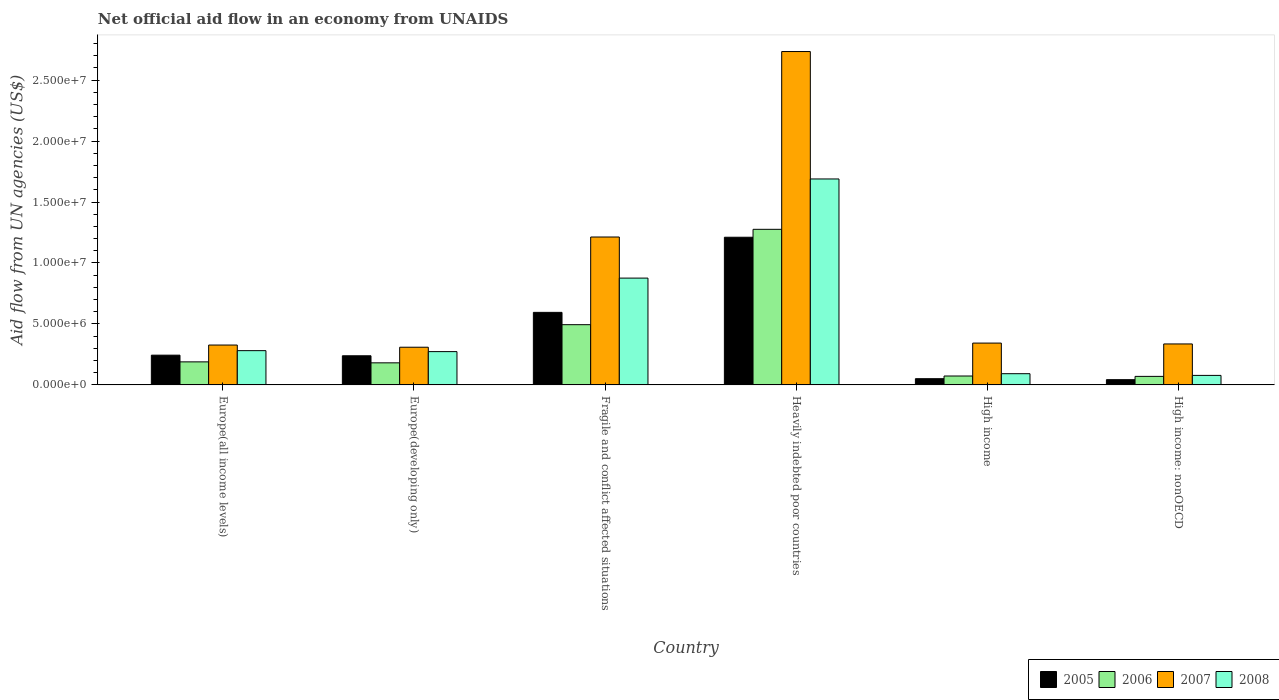How many different coloured bars are there?
Your response must be concise. 4. Are the number of bars per tick equal to the number of legend labels?
Make the answer very short. Yes. Are the number of bars on each tick of the X-axis equal?
Your response must be concise. Yes. How many bars are there on the 1st tick from the left?
Give a very brief answer. 4. How many bars are there on the 4th tick from the right?
Offer a terse response. 4. What is the label of the 3rd group of bars from the left?
Your response must be concise. Fragile and conflict affected situations. In how many cases, is the number of bars for a given country not equal to the number of legend labels?
Offer a very short reply. 0. What is the net official aid flow in 2008 in Europe(developing only)?
Provide a short and direct response. 2.73e+06. Across all countries, what is the maximum net official aid flow in 2005?
Provide a succinct answer. 1.21e+07. Across all countries, what is the minimum net official aid flow in 2005?
Your answer should be very brief. 4.30e+05. In which country was the net official aid flow in 2005 maximum?
Provide a succinct answer. Heavily indebted poor countries. In which country was the net official aid flow in 2005 minimum?
Offer a very short reply. High income: nonOECD. What is the total net official aid flow in 2007 in the graph?
Ensure brevity in your answer.  5.26e+07. What is the difference between the net official aid flow in 2008 in Fragile and conflict affected situations and that in Heavily indebted poor countries?
Your answer should be very brief. -8.13e+06. What is the difference between the net official aid flow in 2008 in High income: nonOECD and the net official aid flow in 2007 in Fragile and conflict affected situations?
Offer a very short reply. -1.14e+07. What is the average net official aid flow in 2007 per country?
Offer a very short reply. 8.77e+06. What is the difference between the net official aid flow of/in 2006 and net official aid flow of/in 2008 in Fragile and conflict affected situations?
Provide a short and direct response. -3.82e+06. What is the ratio of the net official aid flow in 2005 in Europe(developing only) to that in Heavily indebted poor countries?
Your response must be concise. 0.2. Is the net official aid flow in 2005 in Europe(all income levels) less than that in Europe(developing only)?
Your answer should be compact. No. Is the difference between the net official aid flow in 2006 in Europe(developing only) and Heavily indebted poor countries greater than the difference between the net official aid flow in 2008 in Europe(developing only) and Heavily indebted poor countries?
Provide a short and direct response. Yes. What is the difference between the highest and the second highest net official aid flow in 2005?
Make the answer very short. 6.16e+06. What is the difference between the highest and the lowest net official aid flow in 2007?
Your response must be concise. 2.42e+07. In how many countries, is the net official aid flow in 2008 greater than the average net official aid flow in 2008 taken over all countries?
Keep it short and to the point. 2. Is it the case that in every country, the sum of the net official aid flow in 2005 and net official aid flow in 2007 is greater than the sum of net official aid flow in 2008 and net official aid flow in 2006?
Give a very brief answer. No. Is it the case that in every country, the sum of the net official aid flow in 2006 and net official aid flow in 2005 is greater than the net official aid flow in 2007?
Offer a very short reply. No. Does the graph contain any zero values?
Make the answer very short. No. Where does the legend appear in the graph?
Offer a very short reply. Bottom right. What is the title of the graph?
Keep it short and to the point. Net official aid flow in an economy from UNAIDS. What is the label or title of the X-axis?
Your answer should be very brief. Country. What is the label or title of the Y-axis?
Offer a terse response. Aid flow from UN agencies (US$). What is the Aid flow from UN agencies (US$) of 2005 in Europe(all income levels)?
Your answer should be compact. 2.44e+06. What is the Aid flow from UN agencies (US$) in 2006 in Europe(all income levels)?
Your response must be concise. 1.89e+06. What is the Aid flow from UN agencies (US$) in 2007 in Europe(all income levels)?
Provide a short and direct response. 3.27e+06. What is the Aid flow from UN agencies (US$) of 2008 in Europe(all income levels)?
Offer a terse response. 2.81e+06. What is the Aid flow from UN agencies (US$) of 2005 in Europe(developing only)?
Ensure brevity in your answer.  2.39e+06. What is the Aid flow from UN agencies (US$) in 2006 in Europe(developing only)?
Give a very brief answer. 1.81e+06. What is the Aid flow from UN agencies (US$) of 2007 in Europe(developing only)?
Your answer should be compact. 3.09e+06. What is the Aid flow from UN agencies (US$) in 2008 in Europe(developing only)?
Your answer should be very brief. 2.73e+06. What is the Aid flow from UN agencies (US$) in 2005 in Fragile and conflict affected situations?
Make the answer very short. 5.95e+06. What is the Aid flow from UN agencies (US$) in 2006 in Fragile and conflict affected situations?
Ensure brevity in your answer.  4.94e+06. What is the Aid flow from UN agencies (US$) of 2007 in Fragile and conflict affected situations?
Keep it short and to the point. 1.21e+07. What is the Aid flow from UN agencies (US$) in 2008 in Fragile and conflict affected situations?
Make the answer very short. 8.76e+06. What is the Aid flow from UN agencies (US$) of 2005 in Heavily indebted poor countries?
Give a very brief answer. 1.21e+07. What is the Aid flow from UN agencies (US$) of 2006 in Heavily indebted poor countries?
Provide a succinct answer. 1.28e+07. What is the Aid flow from UN agencies (US$) of 2007 in Heavily indebted poor countries?
Ensure brevity in your answer.  2.73e+07. What is the Aid flow from UN agencies (US$) of 2008 in Heavily indebted poor countries?
Offer a terse response. 1.69e+07. What is the Aid flow from UN agencies (US$) of 2005 in High income?
Your response must be concise. 5.10e+05. What is the Aid flow from UN agencies (US$) in 2006 in High income?
Your response must be concise. 7.30e+05. What is the Aid flow from UN agencies (US$) of 2007 in High income?
Your answer should be compact. 3.43e+06. What is the Aid flow from UN agencies (US$) of 2008 in High income?
Your answer should be compact. 9.20e+05. What is the Aid flow from UN agencies (US$) in 2007 in High income: nonOECD?
Make the answer very short. 3.36e+06. What is the Aid flow from UN agencies (US$) of 2008 in High income: nonOECD?
Make the answer very short. 7.80e+05. Across all countries, what is the maximum Aid flow from UN agencies (US$) of 2005?
Your response must be concise. 1.21e+07. Across all countries, what is the maximum Aid flow from UN agencies (US$) of 2006?
Provide a succinct answer. 1.28e+07. Across all countries, what is the maximum Aid flow from UN agencies (US$) in 2007?
Make the answer very short. 2.73e+07. Across all countries, what is the maximum Aid flow from UN agencies (US$) in 2008?
Offer a terse response. 1.69e+07. Across all countries, what is the minimum Aid flow from UN agencies (US$) in 2007?
Offer a very short reply. 3.09e+06. Across all countries, what is the minimum Aid flow from UN agencies (US$) of 2008?
Make the answer very short. 7.80e+05. What is the total Aid flow from UN agencies (US$) in 2005 in the graph?
Give a very brief answer. 2.38e+07. What is the total Aid flow from UN agencies (US$) in 2006 in the graph?
Provide a short and direct response. 2.28e+07. What is the total Aid flow from UN agencies (US$) of 2007 in the graph?
Your answer should be compact. 5.26e+07. What is the total Aid flow from UN agencies (US$) of 2008 in the graph?
Keep it short and to the point. 3.29e+07. What is the difference between the Aid flow from UN agencies (US$) in 2005 in Europe(all income levels) and that in Europe(developing only)?
Your answer should be compact. 5.00e+04. What is the difference between the Aid flow from UN agencies (US$) of 2005 in Europe(all income levels) and that in Fragile and conflict affected situations?
Keep it short and to the point. -3.51e+06. What is the difference between the Aid flow from UN agencies (US$) of 2006 in Europe(all income levels) and that in Fragile and conflict affected situations?
Ensure brevity in your answer.  -3.05e+06. What is the difference between the Aid flow from UN agencies (US$) of 2007 in Europe(all income levels) and that in Fragile and conflict affected situations?
Offer a terse response. -8.86e+06. What is the difference between the Aid flow from UN agencies (US$) of 2008 in Europe(all income levels) and that in Fragile and conflict affected situations?
Your response must be concise. -5.95e+06. What is the difference between the Aid flow from UN agencies (US$) of 2005 in Europe(all income levels) and that in Heavily indebted poor countries?
Offer a very short reply. -9.67e+06. What is the difference between the Aid flow from UN agencies (US$) of 2006 in Europe(all income levels) and that in Heavily indebted poor countries?
Provide a succinct answer. -1.09e+07. What is the difference between the Aid flow from UN agencies (US$) in 2007 in Europe(all income levels) and that in Heavily indebted poor countries?
Keep it short and to the point. -2.41e+07. What is the difference between the Aid flow from UN agencies (US$) in 2008 in Europe(all income levels) and that in Heavily indebted poor countries?
Give a very brief answer. -1.41e+07. What is the difference between the Aid flow from UN agencies (US$) in 2005 in Europe(all income levels) and that in High income?
Offer a terse response. 1.93e+06. What is the difference between the Aid flow from UN agencies (US$) of 2006 in Europe(all income levels) and that in High income?
Offer a very short reply. 1.16e+06. What is the difference between the Aid flow from UN agencies (US$) in 2007 in Europe(all income levels) and that in High income?
Your response must be concise. -1.60e+05. What is the difference between the Aid flow from UN agencies (US$) of 2008 in Europe(all income levels) and that in High income?
Provide a succinct answer. 1.89e+06. What is the difference between the Aid flow from UN agencies (US$) of 2005 in Europe(all income levels) and that in High income: nonOECD?
Provide a short and direct response. 2.01e+06. What is the difference between the Aid flow from UN agencies (US$) in 2006 in Europe(all income levels) and that in High income: nonOECD?
Your answer should be compact. 1.19e+06. What is the difference between the Aid flow from UN agencies (US$) of 2007 in Europe(all income levels) and that in High income: nonOECD?
Your answer should be very brief. -9.00e+04. What is the difference between the Aid flow from UN agencies (US$) in 2008 in Europe(all income levels) and that in High income: nonOECD?
Keep it short and to the point. 2.03e+06. What is the difference between the Aid flow from UN agencies (US$) in 2005 in Europe(developing only) and that in Fragile and conflict affected situations?
Provide a short and direct response. -3.56e+06. What is the difference between the Aid flow from UN agencies (US$) in 2006 in Europe(developing only) and that in Fragile and conflict affected situations?
Your response must be concise. -3.13e+06. What is the difference between the Aid flow from UN agencies (US$) of 2007 in Europe(developing only) and that in Fragile and conflict affected situations?
Offer a terse response. -9.04e+06. What is the difference between the Aid flow from UN agencies (US$) in 2008 in Europe(developing only) and that in Fragile and conflict affected situations?
Ensure brevity in your answer.  -6.03e+06. What is the difference between the Aid flow from UN agencies (US$) of 2005 in Europe(developing only) and that in Heavily indebted poor countries?
Make the answer very short. -9.72e+06. What is the difference between the Aid flow from UN agencies (US$) of 2006 in Europe(developing only) and that in Heavily indebted poor countries?
Give a very brief answer. -1.10e+07. What is the difference between the Aid flow from UN agencies (US$) in 2007 in Europe(developing only) and that in Heavily indebted poor countries?
Offer a terse response. -2.42e+07. What is the difference between the Aid flow from UN agencies (US$) of 2008 in Europe(developing only) and that in Heavily indebted poor countries?
Provide a succinct answer. -1.42e+07. What is the difference between the Aid flow from UN agencies (US$) of 2005 in Europe(developing only) and that in High income?
Your answer should be very brief. 1.88e+06. What is the difference between the Aid flow from UN agencies (US$) of 2006 in Europe(developing only) and that in High income?
Your answer should be very brief. 1.08e+06. What is the difference between the Aid flow from UN agencies (US$) of 2008 in Europe(developing only) and that in High income?
Provide a short and direct response. 1.81e+06. What is the difference between the Aid flow from UN agencies (US$) of 2005 in Europe(developing only) and that in High income: nonOECD?
Offer a very short reply. 1.96e+06. What is the difference between the Aid flow from UN agencies (US$) of 2006 in Europe(developing only) and that in High income: nonOECD?
Your answer should be very brief. 1.11e+06. What is the difference between the Aid flow from UN agencies (US$) in 2008 in Europe(developing only) and that in High income: nonOECD?
Your answer should be compact. 1.95e+06. What is the difference between the Aid flow from UN agencies (US$) of 2005 in Fragile and conflict affected situations and that in Heavily indebted poor countries?
Provide a succinct answer. -6.16e+06. What is the difference between the Aid flow from UN agencies (US$) of 2006 in Fragile and conflict affected situations and that in Heavily indebted poor countries?
Your answer should be compact. -7.82e+06. What is the difference between the Aid flow from UN agencies (US$) of 2007 in Fragile and conflict affected situations and that in Heavily indebted poor countries?
Offer a terse response. -1.52e+07. What is the difference between the Aid flow from UN agencies (US$) of 2008 in Fragile and conflict affected situations and that in Heavily indebted poor countries?
Offer a terse response. -8.13e+06. What is the difference between the Aid flow from UN agencies (US$) in 2005 in Fragile and conflict affected situations and that in High income?
Provide a succinct answer. 5.44e+06. What is the difference between the Aid flow from UN agencies (US$) of 2006 in Fragile and conflict affected situations and that in High income?
Offer a very short reply. 4.21e+06. What is the difference between the Aid flow from UN agencies (US$) in 2007 in Fragile and conflict affected situations and that in High income?
Provide a short and direct response. 8.70e+06. What is the difference between the Aid flow from UN agencies (US$) of 2008 in Fragile and conflict affected situations and that in High income?
Your response must be concise. 7.84e+06. What is the difference between the Aid flow from UN agencies (US$) in 2005 in Fragile and conflict affected situations and that in High income: nonOECD?
Your answer should be very brief. 5.52e+06. What is the difference between the Aid flow from UN agencies (US$) in 2006 in Fragile and conflict affected situations and that in High income: nonOECD?
Ensure brevity in your answer.  4.24e+06. What is the difference between the Aid flow from UN agencies (US$) in 2007 in Fragile and conflict affected situations and that in High income: nonOECD?
Keep it short and to the point. 8.77e+06. What is the difference between the Aid flow from UN agencies (US$) in 2008 in Fragile and conflict affected situations and that in High income: nonOECD?
Make the answer very short. 7.98e+06. What is the difference between the Aid flow from UN agencies (US$) in 2005 in Heavily indebted poor countries and that in High income?
Your answer should be compact. 1.16e+07. What is the difference between the Aid flow from UN agencies (US$) in 2006 in Heavily indebted poor countries and that in High income?
Make the answer very short. 1.20e+07. What is the difference between the Aid flow from UN agencies (US$) of 2007 in Heavily indebted poor countries and that in High income?
Give a very brief answer. 2.39e+07. What is the difference between the Aid flow from UN agencies (US$) in 2008 in Heavily indebted poor countries and that in High income?
Give a very brief answer. 1.60e+07. What is the difference between the Aid flow from UN agencies (US$) of 2005 in Heavily indebted poor countries and that in High income: nonOECD?
Your response must be concise. 1.17e+07. What is the difference between the Aid flow from UN agencies (US$) in 2006 in Heavily indebted poor countries and that in High income: nonOECD?
Provide a succinct answer. 1.21e+07. What is the difference between the Aid flow from UN agencies (US$) of 2007 in Heavily indebted poor countries and that in High income: nonOECD?
Offer a very short reply. 2.40e+07. What is the difference between the Aid flow from UN agencies (US$) in 2008 in Heavily indebted poor countries and that in High income: nonOECD?
Your answer should be compact. 1.61e+07. What is the difference between the Aid flow from UN agencies (US$) in 2005 in High income and that in High income: nonOECD?
Make the answer very short. 8.00e+04. What is the difference between the Aid flow from UN agencies (US$) in 2007 in High income and that in High income: nonOECD?
Keep it short and to the point. 7.00e+04. What is the difference between the Aid flow from UN agencies (US$) in 2005 in Europe(all income levels) and the Aid flow from UN agencies (US$) in 2006 in Europe(developing only)?
Keep it short and to the point. 6.30e+05. What is the difference between the Aid flow from UN agencies (US$) in 2005 in Europe(all income levels) and the Aid flow from UN agencies (US$) in 2007 in Europe(developing only)?
Provide a short and direct response. -6.50e+05. What is the difference between the Aid flow from UN agencies (US$) in 2005 in Europe(all income levels) and the Aid flow from UN agencies (US$) in 2008 in Europe(developing only)?
Give a very brief answer. -2.90e+05. What is the difference between the Aid flow from UN agencies (US$) of 2006 in Europe(all income levels) and the Aid flow from UN agencies (US$) of 2007 in Europe(developing only)?
Your response must be concise. -1.20e+06. What is the difference between the Aid flow from UN agencies (US$) of 2006 in Europe(all income levels) and the Aid flow from UN agencies (US$) of 2008 in Europe(developing only)?
Offer a very short reply. -8.40e+05. What is the difference between the Aid flow from UN agencies (US$) in 2007 in Europe(all income levels) and the Aid flow from UN agencies (US$) in 2008 in Europe(developing only)?
Give a very brief answer. 5.40e+05. What is the difference between the Aid flow from UN agencies (US$) in 2005 in Europe(all income levels) and the Aid flow from UN agencies (US$) in 2006 in Fragile and conflict affected situations?
Keep it short and to the point. -2.50e+06. What is the difference between the Aid flow from UN agencies (US$) in 2005 in Europe(all income levels) and the Aid flow from UN agencies (US$) in 2007 in Fragile and conflict affected situations?
Ensure brevity in your answer.  -9.69e+06. What is the difference between the Aid flow from UN agencies (US$) in 2005 in Europe(all income levels) and the Aid flow from UN agencies (US$) in 2008 in Fragile and conflict affected situations?
Offer a terse response. -6.32e+06. What is the difference between the Aid flow from UN agencies (US$) in 2006 in Europe(all income levels) and the Aid flow from UN agencies (US$) in 2007 in Fragile and conflict affected situations?
Provide a short and direct response. -1.02e+07. What is the difference between the Aid flow from UN agencies (US$) in 2006 in Europe(all income levels) and the Aid flow from UN agencies (US$) in 2008 in Fragile and conflict affected situations?
Your answer should be very brief. -6.87e+06. What is the difference between the Aid flow from UN agencies (US$) in 2007 in Europe(all income levels) and the Aid flow from UN agencies (US$) in 2008 in Fragile and conflict affected situations?
Make the answer very short. -5.49e+06. What is the difference between the Aid flow from UN agencies (US$) of 2005 in Europe(all income levels) and the Aid flow from UN agencies (US$) of 2006 in Heavily indebted poor countries?
Offer a terse response. -1.03e+07. What is the difference between the Aid flow from UN agencies (US$) of 2005 in Europe(all income levels) and the Aid flow from UN agencies (US$) of 2007 in Heavily indebted poor countries?
Ensure brevity in your answer.  -2.49e+07. What is the difference between the Aid flow from UN agencies (US$) in 2005 in Europe(all income levels) and the Aid flow from UN agencies (US$) in 2008 in Heavily indebted poor countries?
Keep it short and to the point. -1.44e+07. What is the difference between the Aid flow from UN agencies (US$) in 2006 in Europe(all income levels) and the Aid flow from UN agencies (US$) in 2007 in Heavily indebted poor countries?
Provide a short and direct response. -2.54e+07. What is the difference between the Aid flow from UN agencies (US$) in 2006 in Europe(all income levels) and the Aid flow from UN agencies (US$) in 2008 in Heavily indebted poor countries?
Provide a short and direct response. -1.50e+07. What is the difference between the Aid flow from UN agencies (US$) in 2007 in Europe(all income levels) and the Aid flow from UN agencies (US$) in 2008 in Heavily indebted poor countries?
Keep it short and to the point. -1.36e+07. What is the difference between the Aid flow from UN agencies (US$) in 2005 in Europe(all income levels) and the Aid flow from UN agencies (US$) in 2006 in High income?
Provide a short and direct response. 1.71e+06. What is the difference between the Aid flow from UN agencies (US$) of 2005 in Europe(all income levels) and the Aid flow from UN agencies (US$) of 2007 in High income?
Your response must be concise. -9.90e+05. What is the difference between the Aid flow from UN agencies (US$) of 2005 in Europe(all income levels) and the Aid flow from UN agencies (US$) of 2008 in High income?
Offer a terse response. 1.52e+06. What is the difference between the Aid flow from UN agencies (US$) of 2006 in Europe(all income levels) and the Aid flow from UN agencies (US$) of 2007 in High income?
Keep it short and to the point. -1.54e+06. What is the difference between the Aid flow from UN agencies (US$) in 2006 in Europe(all income levels) and the Aid flow from UN agencies (US$) in 2008 in High income?
Your response must be concise. 9.70e+05. What is the difference between the Aid flow from UN agencies (US$) of 2007 in Europe(all income levels) and the Aid flow from UN agencies (US$) of 2008 in High income?
Make the answer very short. 2.35e+06. What is the difference between the Aid flow from UN agencies (US$) of 2005 in Europe(all income levels) and the Aid flow from UN agencies (US$) of 2006 in High income: nonOECD?
Your answer should be compact. 1.74e+06. What is the difference between the Aid flow from UN agencies (US$) of 2005 in Europe(all income levels) and the Aid flow from UN agencies (US$) of 2007 in High income: nonOECD?
Your answer should be compact. -9.20e+05. What is the difference between the Aid flow from UN agencies (US$) in 2005 in Europe(all income levels) and the Aid flow from UN agencies (US$) in 2008 in High income: nonOECD?
Provide a short and direct response. 1.66e+06. What is the difference between the Aid flow from UN agencies (US$) in 2006 in Europe(all income levels) and the Aid flow from UN agencies (US$) in 2007 in High income: nonOECD?
Offer a very short reply. -1.47e+06. What is the difference between the Aid flow from UN agencies (US$) in 2006 in Europe(all income levels) and the Aid flow from UN agencies (US$) in 2008 in High income: nonOECD?
Give a very brief answer. 1.11e+06. What is the difference between the Aid flow from UN agencies (US$) of 2007 in Europe(all income levels) and the Aid flow from UN agencies (US$) of 2008 in High income: nonOECD?
Ensure brevity in your answer.  2.49e+06. What is the difference between the Aid flow from UN agencies (US$) of 2005 in Europe(developing only) and the Aid flow from UN agencies (US$) of 2006 in Fragile and conflict affected situations?
Make the answer very short. -2.55e+06. What is the difference between the Aid flow from UN agencies (US$) in 2005 in Europe(developing only) and the Aid flow from UN agencies (US$) in 2007 in Fragile and conflict affected situations?
Provide a succinct answer. -9.74e+06. What is the difference between the Aid flow from UN agencies (US$) of 2005 in Europe(developing only) and the Aid flow from UN agencies (US$) of 2008 in Fragile and conflict affected situations?
Keep it short and to the point. -6.37e+06. What is the difference between the Aid flow from UN agencies (US$) in 2006 in Europe(developing only) and the Aid flow from UN agencies (US$) in 2007 in Fragile and conflict affected situations?
Offer a very short reply. -1.03e+07. What is the difference between the Aid flow from UN agencies (US$) in 2006 in Europe(developing only) and the Aid flow from UN agencies (US$) in 2008 in Fragile and conflict affected situations?
Your answer should be very brief. -6.95e+06. What is the difference between the Aid flow from UN agencies (US$) in 2007 in Europe(developing only) and the Aid flow from UN agencies (US$) in 2008 in Fragile and conflict affected situations?
Your answer should be compact. -5.67e+06. What is the difference between the Aid flow from UN agencies (US$) in 2005 in Europe(developing only) and the Aid flow from UN agencies (US$) in 2006 in Heavily indebted poor countries?
Offer a very short reply. -1.04e+07. What is the difference between the Aid flow from UN agencies (US$) of 2005 in Europe(developing only) and the Aid flow from UN agencies (US$) of 2007 in Heavily indebted poor countries?
Your answer should be very brief. -2.50e+07. What is the difference between the Aid flow from UN agencies (US$) in 2005 in Europe(developing only) and the Aid flow from UN agencies (US$) in 2008 in Heavily indebted poor countries?
Your answer should be very brief. -1.45e+07. What is the difference between the Aid flow from UN agencies (US$) of 2006 in Europe(developing only) and the Aid flow from UN agencies (US$) of 2007 in Heavily indebted poor countries?
Your answer should be very brief. -2.55e+07. What is the difference between the Aid flow from UN agencies (US$) of 2006 in Europe(developing only) and the Aid flow from UN agencies (US$) of 2008 in Heavily indebted poor countries?
Your answer should be very brief. -1.51e+07. What is the difference between the Aid flow from UN agencies (US$) in 2007 in Europe(developing only) and the Aid flow from UN agencies (US$) in 2008 in Heavily indebted poor countries?
Offer a terse response. -1.38e+07. What is the difference between the Aid flow from UN agencies (US$) of 2005 in Europe(developing only) and the Aid flow from UN agencies (US$) of 2006 in High income?
Give a very brief answer. 1.66e+06. What is the difference between the Aid flow from UN agencies (US$) of 2005 in Europe(developing only) and the Aid flow from UN agencies (US$) of 2007 in High income?
Ensure brevity in your answer.  -1.04e+06. What is the difference between the Aid flow from UN agencies (US$) in 2005 in Europe(developing only) and the Aid flow from UN agencies (US$) in 2008 in High income?
Offer a terse response. 1.47e+06. What is the difference between the Aid flow from UN agencies (US$) in 2006 in Europe(developing only) and the Aid flow from UN agencies (US$) in 2007 in High income?
Your answer should be compact. -1.62e+06. What is the difference between the Aid flow from UN agencies (US$) in 2006 in Europe(developing only) and the Aid flow from UN agencies (US$) in 2008 in High income?
Your answer should be very brief. 8.90e+05. What is the difference between the Aid flow from UN agencies (US$) of 2007 in Europe(developing only) and the Aid flow from UN agencies (US$) of 2008 in High income?
Provide a short and direct response. 2.17e+06. What is the difference between the Aid flow from UN agencies (US$) of 2005 in Europe(developing only) and the Aid flow from UN agencies (US$) of 2006 in High income: nonOECD?
Ensure brevity in your answer.  1.69e+06. What is the difference between the Aid flow from UN agencies (US$) in 2005 in Europe(developing only) and the Aid flow from UN agencies (US$) in 2007 in High income: nonOECD?
Provide a short and direct response. -9.70e+05. What is the difference between the Aid flow from UN agencies (US$) in 2005 in Europe(developing only) and the Aid flow from UN agencies (US$) in 2008 in High income: nonOECD?
Offer a terse response. 1.61e+06. What is the difference between the Aid flow from UN agencies (US$) in 2006 in Europe(developing only) and the Aid flow from UN agencies (US$) in 2007 in High income: nonOECD?
Make the answer very short. -1.55e+06. What is the difference between the Aid flow from UN agencies (US$) in 2006 in Europe(developing only) and the Aid flow from UN agencies (US$) in 2008 in High income: nonOECD?
Offer a very short reply. 1.03e+06. What is the difference between the Aid flow from UN agencies (US$) of 2007 in Europe(developing only) and the Aid flow from UN agencies (US$) of 2008 in High income: nonOECD?
Offer a terse response. 2.31e+06. What is the difference between the Aid flow from UN agencies (US$) in 2005 in Fragile and conflict affected situations and the Aid flow from UN agencies (US$) in 2006 in Heavily indebted poor countries?
Your answer should be very brief. -6.81e+06. What is the difference between the Aid flow from UN agencies (US$) of 2005 in Fragile and conflict affected situations and the Aid flow from UN agencies (US$) of 2007 in Heavily indebted poor countries?
Your response must be concise. -2.14e+07. What is the difference between the Aid flow from UN agencies (US$) of 2005 in Fragile and conflict affected situations and the Aid flow from UN agencies (US$) of 2008 in Heavily indebted poor countries?
Offer a very short reply. -1.09e+07. What is the difference between the Aid flow from UN agencies (US$) in 2006 in Fragile and conflict affected situations and the Aid flow from UN agencies (US$) in 2007 in Heavily indebted poor countries?
Provide a succinct answer. -2.24e+07. What is the difference between the Aid flow from UN agencies (US$) of 2006 in Fragile and conflict affected situations and the Aid flow from UN agencies (US$) of 2008 in Heavily indebted poor countries?
Offer a terse response. -1.20e+07. What is the difference between the Aid flow from UN agencies (US$) in 2007 in Fragile and conflict affected situations and the Aid flow from UN agencies (US$) in 2008 in Heavily indebted poor countries?
Your answer should be compact. -4.76e+06. What is the difference between the Aid flow from UN agencies (US$) of 2005 in Fragile and conflict affected situations and the Aid flow from UN agencies (US$) of 2006 in High income?
Your answer should be very brief. 5.22e+06. What is the difference between the Aid flow from UN agencies (US$) in 2005 in Fragile and conflict affected situations and the Aid flow from UN agencies (US$) in 2007 in High income?
Offer a terse response. 2.52e+06. What is the difference between the Aid flow from UN agencies (US$) of 2005 in Fragile and conflict affected situations and the Aid flow from UN agencies (US$) of 2008 in High income?
Your answer should be compact. 5.03e+06. What is the difference between the Aid flow from UN agencies (US$) in 2006 in Fragile and conflict affected situations and the Aid flow from UN agencies (US$) in 2007 in High income?
Your response must be concise. 1.51e+06. What is the difference between the Aid flow from UN agencies (US$) of 2006 in Fragile and conflict affected situations and the Aid flow from UN agencies (US$) of 2008 in High income?
Offer a terse response. 4.02e+06. What is the difference between the Aid flow from UN agencies (US$) in 2007 in Fragile and conflict affected situations and the Aid flow from UN agencies (US$) in 2008 in High income?
Your answer should be compact. 1.12e+07. What is the difference between the Aid flow from UN agencies (US$) of 2005 in Fragile and conflict affected situations and the Aid flow from UN agencies (US$) of 2006 in High income: nonOECD?
Ensure brevity in your answer.  5.25e+06. What is the difference between the Aid flow from UN agencies (US$) in 2005 in Fragile and conflict affected situations and the Aid flow from UN agencies (US$) in 2007 in High income: nonOECD?
Make the answer very short. 2.59e+06. What is the difference between the Aid flow from UN agencies (US$) in 2005 in Fragile and conflict affected situations and the Aid flow from UN agencies (US$) in 2008 in High income: nonOECD?
Your answer should be very brief. 5.17e+06. What is the difference between the Aid flow from UN agencies (US$) of 2006 in Fragile and conflict affected situations and the Aid flow from UN agencies (US$) of 2007 in High income: nonOECD?
Make the answer very short. 1.58e+06. What is the difference between the Aid flow from UN agencies (US$) in 2006 in Fragile and conflict affected situations and the Aid flow from UN agencies (US$) in 2008 in High income: nonOECD?
Your answer should be compact. 4.16e+06. What is the difference between the Aid flow from UN agencies (US$) in 2007 in Fragile and conflict affected situations and the Aid flow from UN agencies (US$) in 2008 in High income: nonOECD?
Ensure brevity in your answer.  1.14e+07. What is the difference between the Aid flow from UN agencies (US$) of 2005 in Heavily indebted poor countries and the Aid flow from UN agencies (US$) of 2006 in High income?
Give a very brief answer. 1.14e+07. What is the difference between the Aid flow from UN agencies (US$) in 2005 in Heavily indebted poor countries and the Aid flow from UN agencies (US$) in 2007 in High income?
Keep it short and to the point. 8.68e+06. What is the difference between the Aid flow from UN agencies (US$) of 2005 in Heavily indebted poor countries and the Aid flow from UN agencies (US$) of 2008 in High income?
Provide a succinct answer. 1.12e+07. What is the difference between the Aid flow from UN agencies (US$) of 2006 in Heavily indebted poor countries and the Aid flow from UN agencies (US$) of 2007 in High income?
Ensure brevity in your answer.  9.33e+06. What is the difference between the Aid flow from UN agencies (US$) of 2006 in Heavily indebted poor countries and the Aid flow from UN agencies (US$) of 2008 in High income?
Keep it short and to the point. 1.18e+07. What is the difference between the Aid flow from UN agencies (US$) of 2007 in Heavily indebted poor countries and the Aid flow from UN agencies (US$) of 2008 in High income?
Your answer should be compact. 2.64e+07. What is the difference between the Aid flow from UN agencies (US$) of 2005 in Heavily indebted poor countries and the Aid flow from UN agencies (US$) of 2006 in High income: nonOECD?
Offer a very short reply. 1.14e+07. What is the difference between the Aid flow from UN agencies (US$) of 2005 in Heavily indebted poor countries and the Aid flow from UN agencies (US$) of 2007 in High income: nonOECD?
Ensure brevity in your answer.  8.75e+06. What is the difference between the Aid flow from UN agencies (US$) in 2005 in Heavily indebted poor countries and the Aid flow from UN agencies (US$) in 2008 in High income: nonOECD?
Your response must be concise. 1.13e+07. What is the difference between the Aid flow from UN agencies (US$) in 2006 in Heavily indebted poor countries and the Aid flow from UN agencies (US$) in 2007 in High income: nonOECD?
Provide a short and direct response. 9.40e+06. What is the difference between the Aid flow from UN agencies (US$) in 2006 in Heavily indebted poor countries and the Aid flow from UN agencies (US$) in 2008 in High income: nonOECD?
Your answer should be compact. 1.20e+07. What is the difference between the Aid flow from UN agencies (US$) in 2007 in Heavily indebted poor countries and the Aid flow from UN agencies (US$) in 2008 in High income: nonOECD?
Your response must be concise. 2.66e+07. What is the difference between the Aid flow from UN agencies (US$) of 2005 in High income and the Aid flow from UN agencies (US$) of 2007 in High income: nonOECD?
Make the answer very short. -2.85e+06. What is the difference between the Aid flow from UN agencies (US$) of 2005 in High income and the Aid flow from UN agencies (US$) of 2008 in High income: nonOECD?
Make the answer very short. -2.70e+05. What is the difference between the Aid flow from UN agencies (US$) of 2006 in High income and the Aid flow from UN agencies (US$) of 2007 in High income: nonOECD?
Ensure brevity in your answer.  -2.63e+06. What is the difference between the Aid flow from UN agencies (US$) of 2006 in High income and the Aid flow from UN agencies (US$) of 2008 in High income: nonOECD?
Your answer should be compact. -5.00e+04. What is the difference between the Aid flow from UN agencies (US$) in 2007 in High income and the Aid flow from UN agencies (US$) in 2008 in High income: nonOECD?
Provide a short and direct response. 2.65e+06. What is the average Aid flow from UN agencies (US$) of 2005 per country?
Provide a short and direct response. 3.97e+06. What is the average Aid flow from UN agencies (US$) of 2006 per country?
Offer a terse response. 3.80e+06. What is the average Aid flow from UN agencies (US$) in 2007 per country?
Your answer should be compact. 8.77e+06. What is the average Aid flow from UN agencies (US$) in 2008 per country?
Give a very brief answer. 5.48e+06. What is the difference between the Aid flow from UN agencies (US$) of 2005 and Aid flow from UN agencies (US$) of 2007 in Europe(all income levels)?
Keep it short and to the point. -8.30e+05. What is the difference between the Aid flow from UN agencies (US$) of 2005 and Aid flow from UN agencies (US$) of 2008 in Europe(all income levels)?
Provide a succinct answer. -3.70e+05. What is the difference between the Aid flow from UN agencies (US$) of 2006 and Aid flow from UN agencies (US$) of 2007 in Europe(all income levels)?
Provide a succinct answer. -1.38e+06. What is the difference between the Aid flow from UN agencies (US$) of 2006 and Aid flow from UN agencies (US$) of 2008 in Europe(all income levels)?
Offer a terse response. -9.20e+05. What is the difference between the Aid flow from UN agencies (US$) in 2005 and Aid flow from UN agencies (US$) in 2006 in Europe(developing only)?
Give a very brief answer. 5.80e+05. What is the difference between the Aid flow from UN agencies (US$) in 2005 and Aid flow from UN agencies (US$) in 2007 in Europe(developing only)?
Offer a very short reply. -7.00e+05. What is the difference between the Aid flow from UN agencies (US$) in 2005 and Aid flow from UN agencies (US$) in 2008 in Europe(developing only)?
Offer a very short reply. -3.40e+05. What is the difference between the Aid flow from UN agencies (US$) of 2006 and Aid flow from UN agencies (US$) of 2007 in Europe(developing only)?
Your answer should be very brief. -1.28e+06. What is the difference between the Aid flow from UN agencies (US$) of 2006 and Aid flow from UN agencies (US$) of 2008 in Europe(developing only)?
Your answer should be very brief. -9.20e+05. What is the difference between the Aid flow from UN agencies (US$) of 2005 and Aid flow from UN agencies (US$) of 2006 in Fragile and conflict affected situations?
Offer a terse response. 1.01e+06. What is the difference between the Aid flow from UN agencies (US$) of 2005 and Aid flow from UN agencies (US$) of 2007 in Fragile and conflict affected situations?
Provide a succinct answer. -6.18e+06. What is the difference between the Aid flow from UN agencies (US$) of 2005 and Aid flow from UN agencies (US$) of 2008 in Fragile and conflict affected situations?
Your response must be concise. -2.81e+06. What is the difference between the Aid flow from UN agencies (US$) of 2006 and Aid flow from UN agencies (US$) of 2007 in Fragile and conflict affected situations?
Provide a succinct answer. -7.19e+06. What is the difference between the Aid flow from UN agencies (US$) of 2006 and Aid flow from UN agencies (US$) of 2008 in Fragile and conflict affected situations?
Give a very brief answer. -3.82e+06. What is the difference between the Aid flow from UN agencies (US$) of 2007 and Aid flow from UN agencies (US$) of 2008 in Fragile and conflict affected situations?
Ensure brevity in your answer.  3.37e+06. What is the difference between the Aid flow from UN agencies (US$) of 2005 and Aid flow from UN agencies (US$) of 2006 in Heavily indebted poor countries?
Your response must be concise. -6.50e+05. What is the difference between the Aid flow from UN agencies (US$) in 2005 and Aid flow from UN agencies (US$) in 2007 in Heavily indebted poor countries?
Ensure brevity in your answer.  -1.52e+07. What is the difference between the Aid flow from UN agencies (US$) of 2005 and Aid flow from UN agencies (US$) of 2008 in Heavily indebted poor countries?
Your answer should be very brief. -4.78e+06. What is the difference between the Aid flow from UN agencies (US$) in 2006 and Aid flow from UN agencies (US$) in 2007 in Heavily indebted poor countries?
Ensure brevity in your answer.  -1.46e+07. What is the difference between the Aid flow from UN agencies (US$) in 2006 and Aid flow from UN agencies (US$) in 2008 in Heavily indebted poor countries?
Keep it short and to the point. -4.13e+06. What is the difference between the Aid flow from UN agencies (US$) of 2007 and Aid flow from UN agencies (US$) of 2008 in Heavily indebted poor countries?
Keep it short and to the point. 1.04e+07. What is the difference between the Aid flow from UN agencies (US$) in 2005 and Aid flow from UN agencies (US$) in 2006 in High income?
Your response must be concise. -2.20e+05. What is the difference between the Aid flow from UN agencies (US$) of 2005 and Aid flow from UN agencies (US$) of 2007 in High income?
Make the answer very short. -2.92e+06. What is the difference between the Aid flow from UN agencies (US$) of 2005 and Aid flow from UN agencies (US$) of 2008 in High income?
Your answer should be very brief. -4.10e+05. What is the difference between the Aid flow from UN agencies (US$) of 2006 and Aid flow from UN agencies (US$) of 2007 in High income?
Provide a succinct answer. -2.70e+06. What is the difference between the Aid flow from UN agencies (US$) in 2007 and Aid flow from UN agencies (US$) in 2008 in High income?
Give a very brief answer. 2.51e+06. What is the difference between the Aid flow from UN agencies (US$) of 2005 and Aid flow from UN agencies (US$) of 2007 in High income: nonOECD?
Provide a succinct answer. -2.93e+06. What is the difference between the Aid flow from UN agencies (US$) of 2005 and Aid flow from UN agencies (US$) of 2008 in High income: nonOECD?
Make the answer very short. -3.50e+05. What is the difference between the Aid flow from UN agencies (US$) of 2006 and Aid flow from UN agencies (US$) of 2007 in High income: nonOECD?
Make the answer very short. -2.66e+06. What is the difference between the Aid flow from UN agencies (US$) in 2007 and Aid flow from UN agencies (US$) in 2008 in High income: nonOECD?
Make the answer very short. 2.58e+06. What is the ratio of the Aid flow from UN agencies (US$) of 2005 in Europe(all income levels) to that in Europe(developing only)?
Your answer should be compact. 1.02. What is the ratio of the Aid flow from UN agencies (US$) in 2006 in Europe(all income levels) to that in Europe(developing only)?
Your answer should be very brief. 1.04. What is the ratio of the Aid flow from UN agencies (US$) in 2007 in Europe(all income levels) to that in Europe(developing only)?
Your answer should be compact. 1.06. What is the ratio of the Aid flow from UN agencies (US$) in 2008 in Europe(all income levels) to that in Europe(developing only)?
Offer a very short reply. 1.03. What is the ratio of the Aid flow from UN agencies (US$) in 2005 in Europe(all income levels) to that in Fragile and conflict affected situations?
Make the answer very short. 0.41. What is the ratio of the Aid flow from UN agencies (US$) in 2006 in Europe(all income levels) to that in Fragile and conflict affected situations?
Provide a succinct answer. 0.38. What is the ratio of the Aid flow from UN agencies (US$) of 2007 in Europe(all income levels) to that in Fragile and conflict affected situations?
Offer a terse response. 0.27. What is the ratio of the Aid flow from UN agencies (US$) in 2008 in Europe(all income levels) to that in Fragile and conflict affected situations?
Make the answer very short. 0.32. What is the ratio of the Aid flow from UN agencies (US$) of 2005 in Europe(all income levels) to that in Heavily indebted poor countries?
Make the answer very short. 0.2. What is the ratio of the Aid flow from UN agencies (US$) in 2006 in Europe(all income levels) to that in Heavily indebted poor countries?
Make the answer very short. 0.15. What is the ratio of the Aid flow from UN agencies (US$) in 2007 in Europe(all income levels) to that in Heavily indebted poor countries?
Provide a succinct answer. 0.12. What is the ratio of the Aid flow from UN agencies (US$) in 2008 in Europe(all income levels) to that in Heavily indebted poor countries?
Your response must be concise. 0.17. What is the ratio of the Aid flow from UN agencies (US$) in 2005 in Europe(all income levels) to that in High income?
Your answer should be compact. 4.78. What is the ratio of the Aid flow from UN agencies (US$) of 2006 in Europe(all income levels) to that in High income?
Give a very brief answer. 2.59. What is the ratio of the Aid flow from UN agencies (US$) of 2007 in Europe(all income levels) to that in High income?
Offer a very short reply. 0.95. What is the ratio of the Aid flow from UN agencies (US$) in 2008 in Europe(all income levels) to that in High income?
Give a very brief answer. 3.05. What is the ratio of the Aid flow from UN agencies (US$) of 2005 in Europe(all income levels) to that in High income: nonOECD?
Keep it short and to the point. 5.67. What is the ratio of the Aid flow from UN agencies (US$) in 2007 in Europe(all income levels) to that in High income: nonOECD?
Provide a succinct answer. 0.97. What is the ratio of the Aid flow from UN agencies (US$) in 2008 in Europe(all income levels) to that in High income: nonOECD?
Your response must be concise. 3.6. What is the ratio of the Aid flow from UN agencies (US$) of 2005 in Europe(developing only) to that in Fragile and conflict affected situations?
Make the answer very short. 0.4. What is the ratio of the Aid flow from UN agencies (US$) in 2006 in Europe(developing only) to that in Fragile and conflict affected situations?
Your answer should be very brief. 0.37. What is the ratio of the Aid flow from UN agencies (US$) of 2007 in Europe(developing only) to that in Fragile and conflict affected situations?
Give a very brief answer. 0.25. What is the ratio of the Aid flow from UN agencies (US$) of 2008 in Europe(developing only) to that in Fragile and conflict affected situations?
Your response must be concise. 0.31. What is the ratio of the Aid flow from UN agencies (US$) of 2005 in Europe(developing only) to that in Heavily indebted poor countries?
Your answer should be compact. 0.2. What is the ratio of the Aid flow from UN agencies (US$) in 2006 in Europe(developing only) to that in Heavily indebted poor countries?
Offer a terse response. 0.14. What is the ratio of the Aid flow from UN agencies (US$) of 2007 in Europe(developing only) to that in Heavily indebted poor countries?
Provide a short and direct response. 0.11. What is the ratio of the Aid flow from UN agencies (US$) of 2008 in Europe(developing only) to that in Heavily indebted poor countries?
Your answer should be very brief. 0.16. What is the ratio of the Aid flow from UN agencies (US$) of 2005 in Europe(developing only) to that in High income?
Your answer should be very brief. 4.69. What is the ratio of the Aid flow from UN agencies (US$) in 2006 in Europe(developing only) to that in High income?
Provide a short and direct response. 2.48. What is the ratio of the Aid flow from UN agencies (US$) of 2007 in Europe(developing only) to that in High income?
Keep it short and to the point. 0.9. What is the ratio of the Aid flow from UN agencies (US$) in 2008 in Europe(developing only) to that in High income?
Make the answer very short. 2.97. What is the ratio of the Aid flow from UN agencies (US$) of 2005 in Europe(developing only) to that in High income: nonOECD?
Provide a succinct answer. 5.56. What is the ratio of the Aid flow from UN agencies (US$) in 2006 in Europe(developing only) to that in High income: nonOECD?
Offer a terse response. 2.59. What is the ratio of the Aid flow from UN agencies (US$) in 2007 in Europe(developing only) to that in High income: nonOECD?
Keep it short and to the point. 0.92. What is the ratio of the Aid flow from UN agencies (US$) in 2008 in Europe(developing only) to that in High income: nonOECD?
Provide a short and direct response. 3.5. What is the ratio of the Aid flow from UN agencies (US$) in 2005 in Fragile and conflict affected situations to that in Heavily indebted poor countries?
Your answer should be very brief. 0.49. What is the ratio of the Aid flow from UN agencies (US$) of 2006 in Fragile and conflict affected situations to that in Heavily indebted poor countries?
Make the answer very short. 0.39. What is the ratio of the Aid flow from UN agencies (US$) in 2007 in Fragile and conflict affected situations to that in Heavily indebted poor countries?
Provide a short and direct response. 0.44. What is the ratio of the Aid flow from UN agencies (US$) of 2008 in Fragile and conflict affected situations to that in Heavily indebted poor countries?
Your response must be concise. 0.52. What is the ratio of the Aid flow from UN agencies (US$) of 2005 in Fragile and conflict affected situations to that in High income?
Your response must be concise. 11.67. What is the ratio of the Aid flow from UN agencies (US$) of 2006 in Fragile and conflict affected situations to that in High income?
Offer a very short reply. 6.77. What is the ratio of the Aid flow from UN agencies (US$) of 2007 in Fragile and conflict affected situations to that in High income?
Offer a very short reply. 3.54. What is the ratio of the Aid flow from UN agencies (US$) of 2008 in Fragile and conflict affected situations to that in High income?
Keep it short and to the point. 9.52. What is the ratio of the Aid flow from UN agencies (US$) of 2005 in Fragile and conflict affected situations to that in High income: nonOECD?
Your answer should be very brief. 13.84. What is the ratio of the Aid flow from UN agencies (US$) in 2006 in Fragile and conflict affected situations to that in High income: nonOECD?
Keep it short and to the point. 7.06. What is the ratio of the Aid flow from UN agencies (US$) in 2007 in Fragile and conflict affected situations to that in High income: nonOECD?
Offer a terse response. 3.61. What is the ratio of the Aid flow from UN agencies (US$) in 2008 in Fragile and conflict affected situations to that in High income: nonOECD?
Your answer should be very brief. 11.23. What is the ratio of the Aid flow from UN agencies (US$) of 2005 in Heavily indebted poor countries to that in High income?
Your answer should be very brief. 23.75. What is the ratio of the Aid flow from UN agencies (US$) in 2006 in Heavily indebted poor countries to that in High income?
Your response must be concise. 17.48. What is the ratio of the Aid flow from UN agencies (US$) in 2007 in Heavily indebted poor countries to that in High income?
Keep it short and to the point. 7.97. What is the ratio of the Aid flow from UN agencies (US$) of 2008 in Heavily indebted poor countries to that in High income?
Ensure brevity in your answer.  18.36. What is the ratio of the Aid flow from UN agencies (US$) in 2005 in Heavily indebted poor countries to that in High income: nonOECD?
Provide a succinct answer. 28.16. What is the ratio of the Aid flow from UN agencies (US$) in 2006 in Heavily indebted poor countries to that in High income: nonOECD?
Ensure brevity in your answer.  18.23. What is the ratio of the Aid flow from UN agencies (US$) of 2007 in Heavily indebted poor countries to that in High income: nonOECD?
Offer a very short reply. 8.14. What is the ratio of the Aid flow from UN agencies (US$) of 2008 in Heavily indebted poor countries to that in High income: nonOECD?
Provide a short and direct response. 21.65. What is the ratio of the Aid flow from UN agencies (US$) of 2005 in High income to that in High income: nonOECD?
Give a very brief answer. 1.19. What is the ratio of the Aid flow from UN agencies (US$) of 2006 in High income to that in High income: nonOECD?
Offer a terse response. 1.04. What is the ratio of the Aid flow from UN agencies (US$) of 2007 in High income to that in High income: nonOECD?
Keep it short and to the point. 1.02. What is the ratio of the Aid flow from UN agencies (US$) in 2008 in High income to that in High income: nonOECD?
Make the answer very short. 1.18. What is the difference between the highest and the second highest Aid flow from UN agencies (US$) of 2005?
Your response must be concise. 6.16e+06. What is the difference between the highest and the second highest Aid flow from UN agencies (US$) of 2006?
Your answer should be compact. 7.82e+06. What is the difference between the highest and the second highest Aid flow from UN agencies (US$) of 2007?
Give a very brief answer. 1.52e+07. What is the difference between the highest and the second highest Aid flow from UN agencies (US$) in 2008?
Your answer should be very brief. 8.13e+06. What is the difference between the highest and the lowest Aid flow from UN agencies (US$) in 2005?
Your answer should be compact. 1.17e+07. What is the difference between the highest and the lowest Aid flow from UN agencies (US$) in 2006?
Your answer should be very brief. 1.21e+07. What is the difference between the highest and the lowest Aid flow from UN agencies (US$) of 2007?
Your answer should be very brief. 2.42e+07. What is the difference between the highest and the lowest Aid flow from UN agencies (US$) of 2008?
Keep it short and to the point. 1.61e+07. 